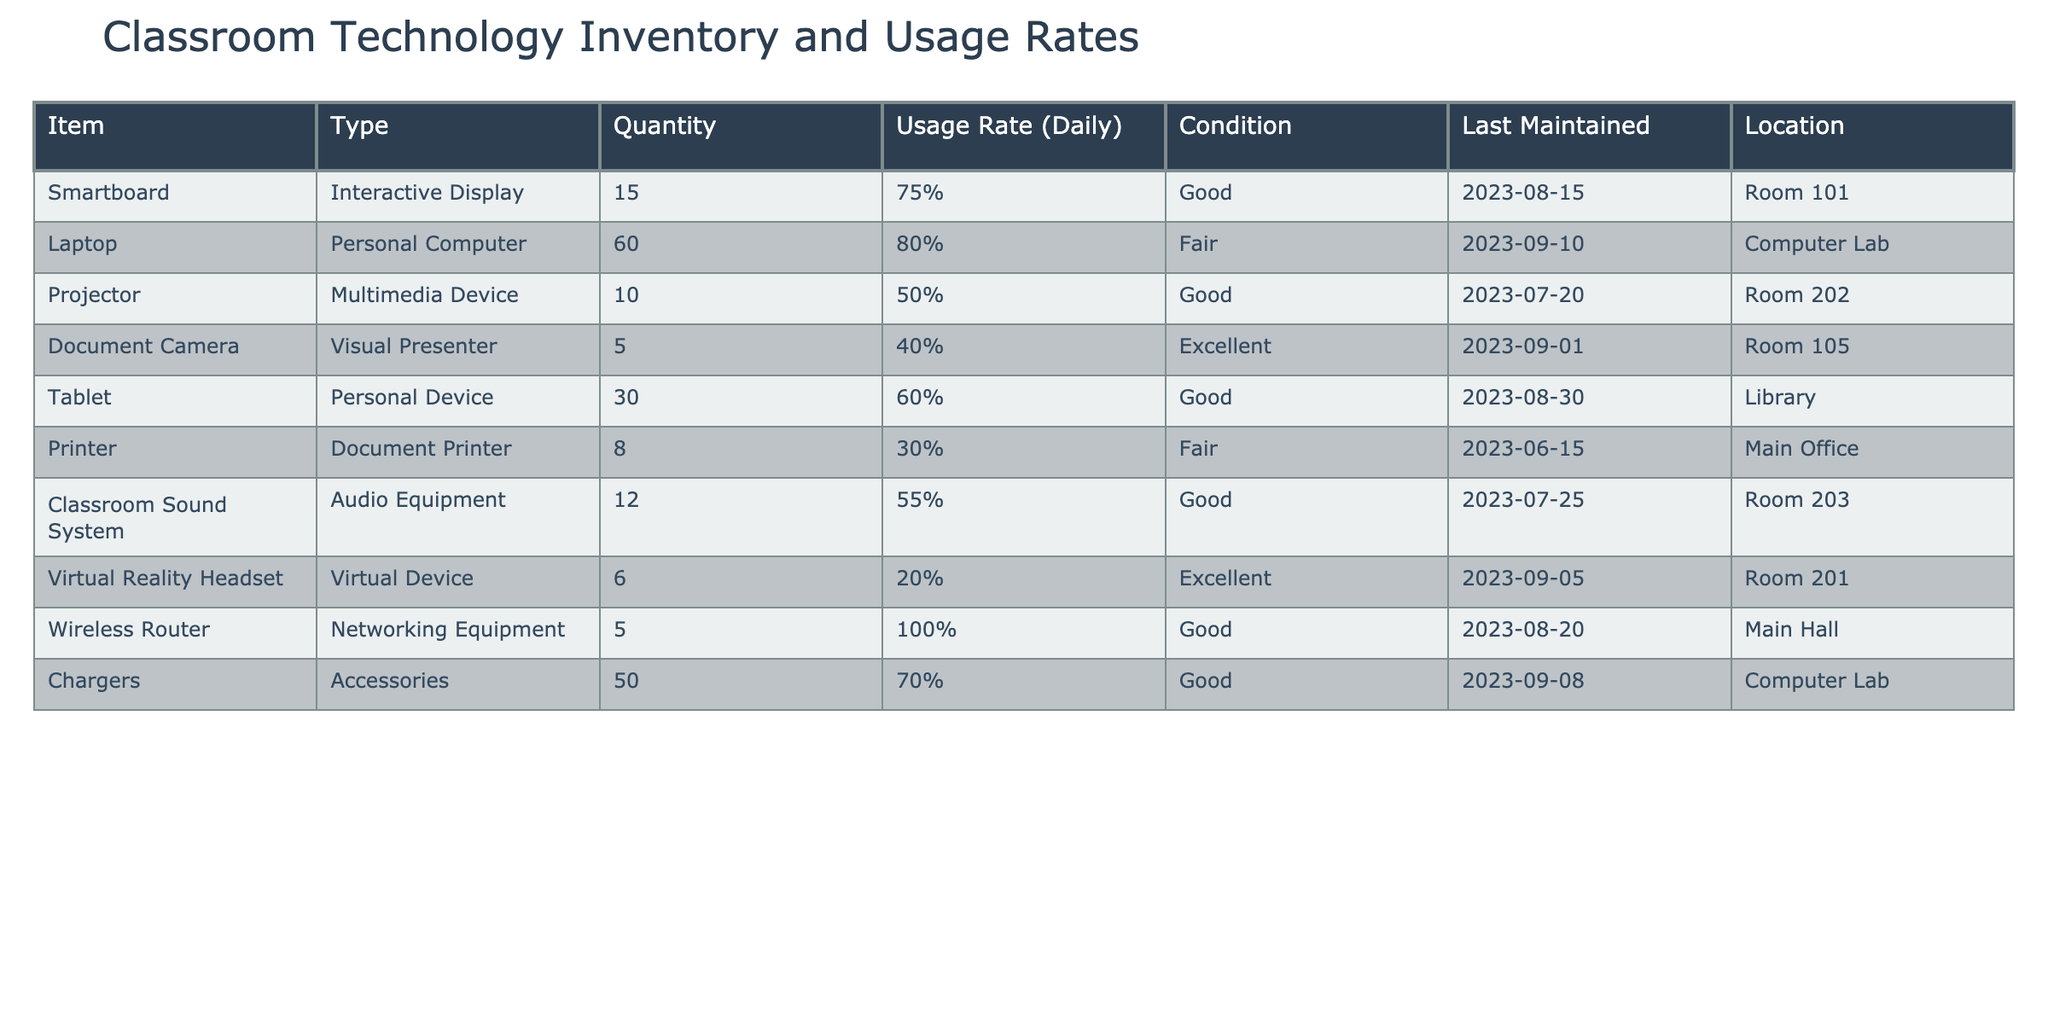What is the location of the Smartboard? The row for the Smartboard lists the location as Room 101.
Answer: Room 101 How many laptops are in fair condition? The table shows that there are 60 laptops, and their condition is noted as fair.
Answer: 60 What is the average usage rate of all devices listed in the table? To find the average usage rate, convert the percentages to decimals: 0.75, 0.80, 0.50, 0.40, 0.60, 0.30, 0.55, 0.20, 1.00, 0.70. Summing these gives 4.10, then dividing by the count of items (10) gives an average of 0.41 or 41%.
Answer: 41% Is any device located in the Computer Lab? Yes, both the Laptop and Chargers are listed as being located in the Computer Lab according to the table.
Answer: Yes Which device has the highest usage rate, and what is that rate? The Wireless Router has the highest usage rate at 100%, as indicated in the table.
Answer: Wireless Router, 100% How many devices have a usage rate of 50% or less, and what are they? The devices with 50% or less usage rates are the Projector (50%), Document Camera (40%), Printer (30%), and Virtual Reality Headset (20%). This gives a total of four devices.
Answer: 4: Projector, Document Camera, Printer, Virtual Reality Headset Are all devices in good condition or better? No, two devices are listed as being in fair condition (Laptop and Printer) indicating that not all devices are in good condition.
Answer: No Considering the last maintained date, which device needs maintenance the most urgently? The Printer was last maintained on 2023-06-15, which is the earliest date compared to others, indicating it requires maintenance most urgently.
Answer: Printer 